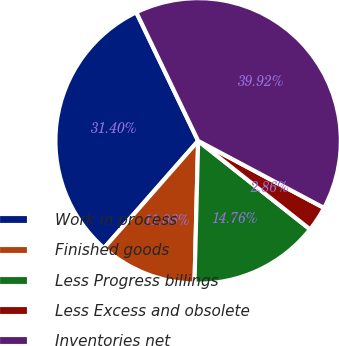Convert chart to OTSL. <chart><loc_0><loc_0><loc_500><loc_500><pie_chart><fcel>Work in process<fcel>Finished goods<fcel>Less Progress billings<fcel>Less Excess and obsolete<fcel>Inventories net<nl><fcel>31.4%<fcel>11.06%<fcel>14.76%<fcel>2.86%<fcel>39.92%<nl></chart> 